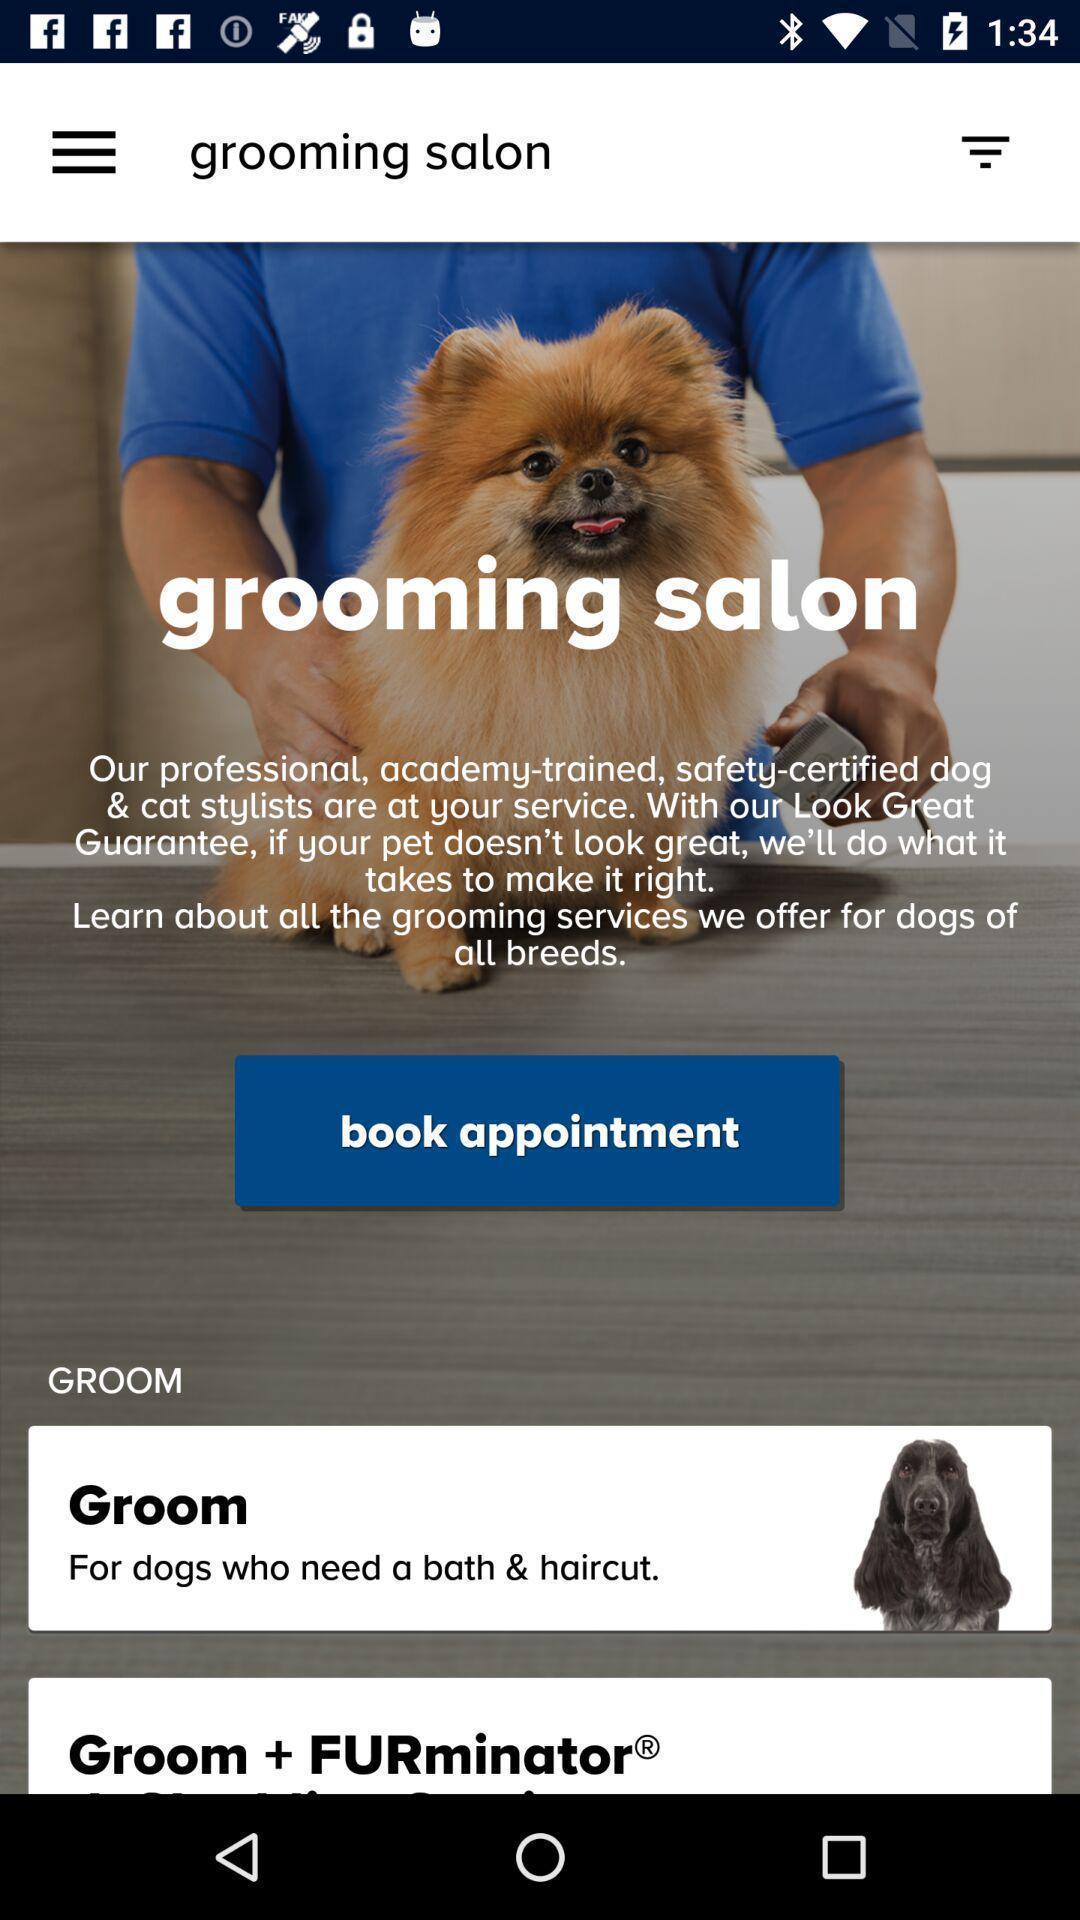Describe the visual elements of this screenshot. Page shows for booking an appointment. 